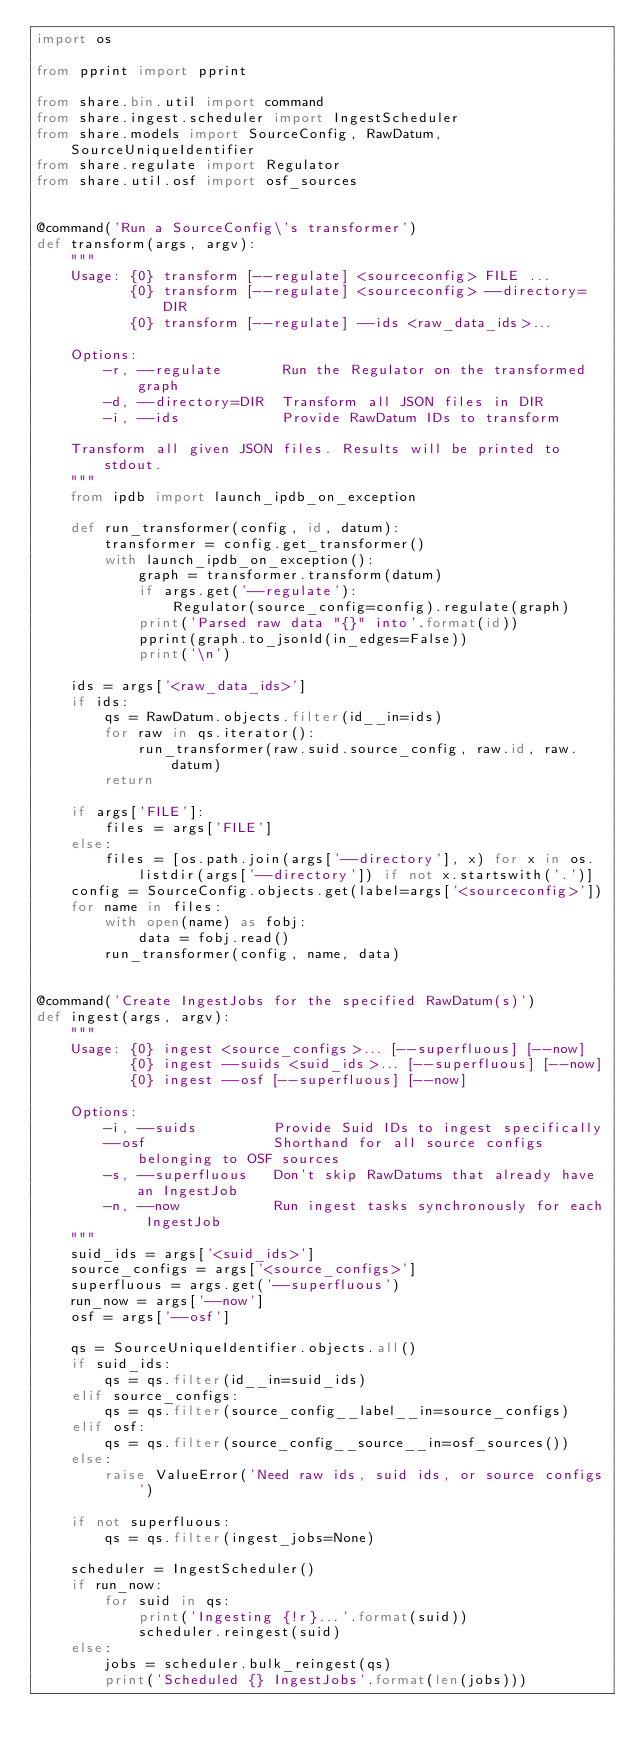<code> <loc_0><loc_0><loc_500><loc_500><_Python_>import os

from pprint import pprint

from share.bin.util import command
from share.ingest.scheduler import IngestScheduler
from share.models import SourceConfig, RawDatum, SourceUniqueIdentifier
from share.regulate import Regulator
from share.util.osf import osf_sources


@command('Run a SourceConfig\'s transformer')
def transform(args, argv):
    """
    Usage: {0} transform [--regulate] <sourceconfig> FILE ...
           {0} transform [--regulate] <sourceconfig> --directory=DIR
           {0} transform [--regulate] --ids <raw_data_ids>...

    Options:
        -r, --regulate       Run the Regulator on the transformed graph
        -d, --directory=DIR  Transform all JSON files in DIR
        -i, --ids            Provide RawDatum IDs to transform

    Transform all given JSON files. Results will be printed to stdout.
    """
    from ipdb import launch_ipdb_on_exception

    def run_transformer(config, id, datum):
        transformer = config.get_transformer()
        with launch_ipdb_on_exception():
            graph = transformer.transform(datum)
            if args.get('--regulate'):
                Regulator(source_config=config).regulate(graph)
            print('Parsed raw data "{}" into'.format(id))
            pprint(graph.to_jsonld(in_edges=False))
            print('\n')

    ids = args['<raw_data_ids>']
    if ids:
        qs = RawDatum.objects.filter(id__in=ids)
        for raw in qs.iterator():
            run_transformer(raw.suid.source_config, raw.id, raw.datum)
        return

    if args['FILE']:
        files = args['FILE']
    else:
        files = [os.path.join(args['--directory'], x) for x in os.listdir(args['--directory']) if not x.startswith('.')]
    config = SourceConfig.objects.get(label=args['<sourceconfig>'])
    for name in files:
        with open(name) as fobj:
            data = fobj.read()
        run_transformer(config, name, data)


@command('Create IngestJobs for the specified RawDatum(s)')
def ingest(args, argv):
    """
    Usage: {0} ingest <source_configs>... [--superfluous] [--now]
           {0} ingest --suids <suid_ids>... [--superfluous] [--now]
           {0} ingest --osf [--superfluous] [--now]

    Options:
        -i, --suids         Provide Suid IDs to ingest specifically
        --osf               Shorthand for all source configs belonging to OSF sources
        -s, --superfluous   Don't skip RawDatums that already have an IngestJob
        -n, --now           Run ingest tasks synchronously for each IngestJob
    """
    suid_ids = args['<suid_ids>']
    source_configs = args['<source_configs>']
    superfluous = args.get('--superfluous')
    run_now = args['--now']
    osf = args['--osf']

    qs = SourceUniqueIdentifier.objects.all()
    if suid_ids:
        qs = qs.filter(id__in=suid_ids)
    elif source_configs:
        qs = qs.filter(source_config__label__in=source_configs)
    elif osf:
        qs = qs.filter(source_config__source__in=osf_sources())
    else:
        raise ValueError('Need raw ids, suid ids, or source configs')

    if not superfluous:
        qs = qs.filter(ingest_jobs=None)

    scheduler = IngestScheduler()
    if run_now:
        for suid in qs:
            print('Ingesting {!r}...'.format(suid))
            scheduler.reingest(suid)
    else:
        jobs = scheduler.bulk_reingest(qs)
        print('Scheduled {} IngestJobs'.format(len(jobs)))
</code> 